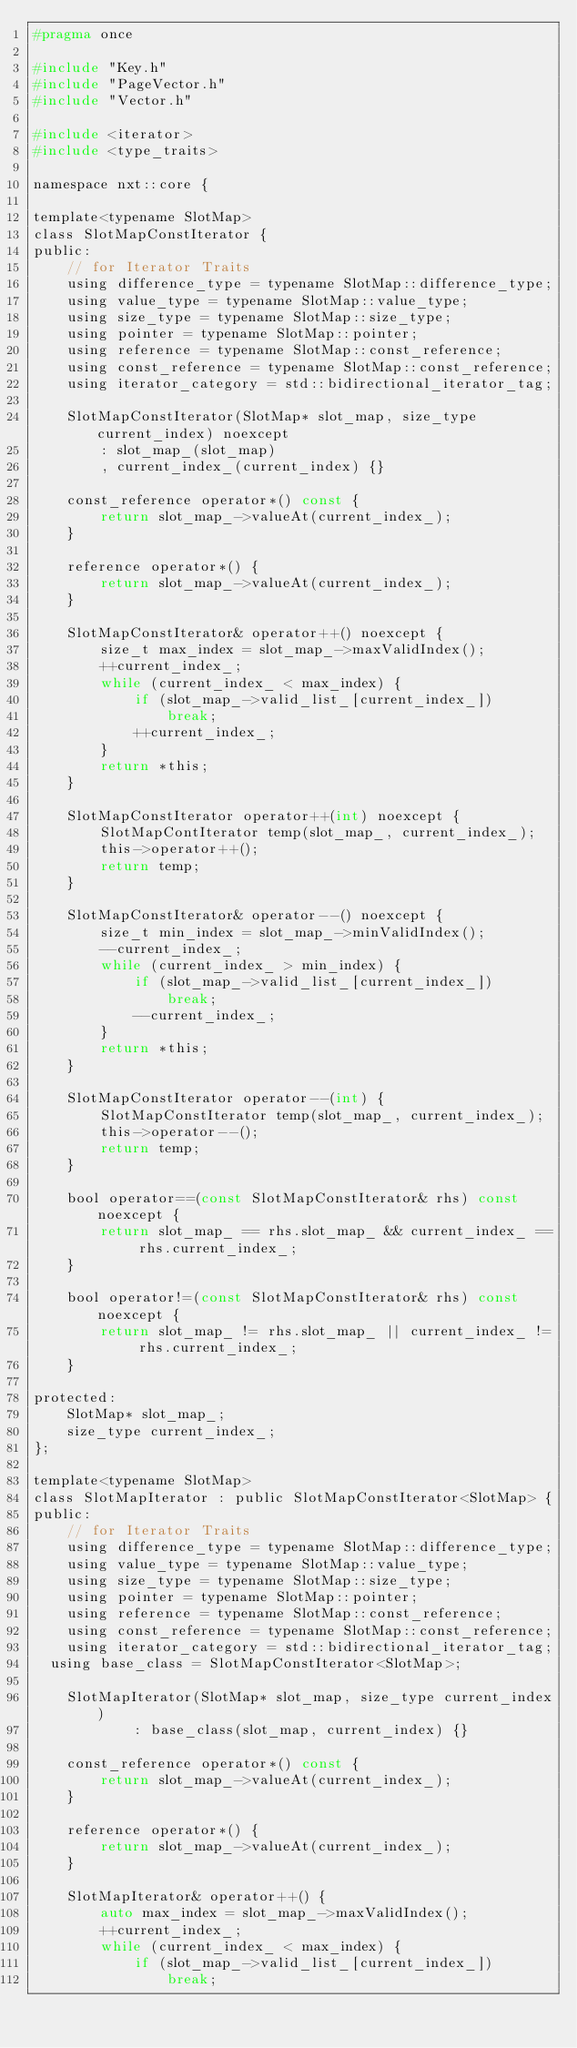<code> <loc_0><loc_0><loc_500><loc_500><_C_>#pragma once

#include "Key.h"
#include "PageVector.h"
#include "Vector.h"

#include <iterator>
#include <type_traits>

namespace nxt::core {

template<typename SlotMap>
class SlotMapConstIterator {
public:
    // for Iterator Traits
    using difference_type = typename SlotMap::difference_type;
    using value_type = typename SlotMap::value_type;
    using size_type = typename SlotMap::size_type;
    using pointer = typename SlotMap::pointer;
    using reference = typename SlotMap::const_reference;
    using const_reference = typename SlotMap::const_reference;
    using iterator_category = std::bidirectional_iterator_tag;

    SlotMapConstIterator(SlotMap* slot_map, size_type current_index) noexcept
        : slot_map_(slot_map)
        , current_index_(current_index) {}

    const_reference operator*() const {
        return slot_map_->valueAt(current_index_);
    }

    reference operator*() {
        return slot_map_->valueAt(current_index_);
    }

    SlotMapConstIterator& operator++() noexcept {
        size_t max_index = slot_map_->maxValidIndex();
        ++current_index_;
        while (current_index_ < max_index) {
            if (slot_map_->valid_list_[current_index_])
                break;
            ++current_index_;
        }
        return *this;
    }

    SlotMapConstIterator operator++(int) noexcept {
        SlotMapContIterator temp(slot_map_, current_index_);
        this->operator++();
        return temp;
    }

    SlotMapConstIterator& operator--() noexcept {
        size_t min_index = slot_map_->minValidIndex();
        --current_index_;
        while (current_index_ > min_index) {
            if (slot_map_->valid_list_[current_index_])
                break;
            --current_index_;
        }
        return *this;
    }

    SlotMapConstIterator operator--(int) {
        SlotMapConstIterator temp(slot_map_, current_index_);
        this->operator--();
        return temp;
    }

    bool operator==(const SlotMapConstIterator& rhs) const noexcept {
        return slot_map_ == rhs.slot_map_ && current_index_ == rhs.current_index_;
    }

    bool operator!=(const SlotMapConstIterator& rhs) const noexcept {
        return slot_map_ != rhs.slot_map_ || current_index_ != rhs.current_index_;
    }

protected:
    SlotMap* slot_map_;
    size_type current_index_;
};

template<typename SlotMap>
class SlotMapIterator : public SlotMapConstIterator<SlotMap> {
public:
    // for Iterator Traits
    using difference_type = typename SlotMap::difference_type;
    using value_type = typename SlotMap::value_type;
    using size_type = typename SlotMap::size_type;
    using pointer = typename SlotMap::pointer;
    using reference = typename SlotMap::const_reference;
    using const_reference = typename SlotMap::const_reference;
    using iterator_category = std::bidirectional_iterator_tag;
	using base_class = SlotMapConstIterator<SlotMap>;

    SlotMapIterator(SlotMap* slot_map, size_type current_index)
            : base_class(slot_map, current_index) {}

    const_reference operator*() const {
        return slot_map_->valueAt(current_index_);
    }

    reference operator*() {
        return slot_map_->valueAt(current_index_);
    }

    SlotMapIterator& operator++() {
        auto max_index = slot_map_->maxValidIndex();
        ++current_index_;
        while (current_index_ < max_index) {
            if (slot_map_->valid_list_[current_index_])
                break;</code> 